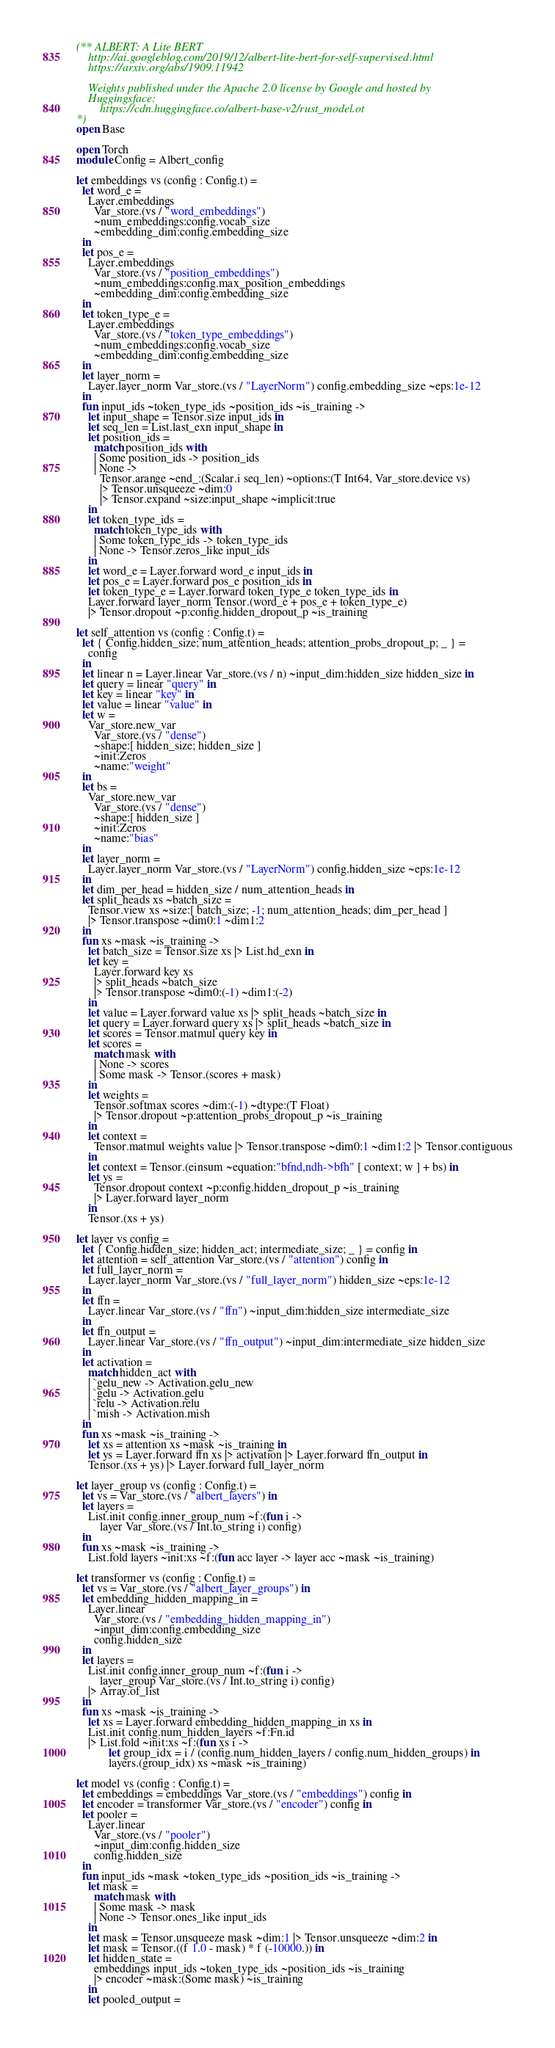<code> <loc_0><loc_0><loc_500><loc_500><_OCaml_>(** ALBERT: A Lite BERT
    http://ai.googleblog.com/2019/12/albert-lite-bert-for-self-supervised.html
    https://arxiv.org/abs/1909.11942

    Weights published under the Apache 2.0 license by Google and hosted by
    Huggingsface:
        https://cdn.huggingface.co/albert-base-v2/rust_model.ot
*)
open Base

open Torch
module Config = Albert_config

let embeddings vs (config : Config.t) =
  let word_e =
    Layer.embeddings
      Var_store.(vs / "word_embeddings")
      ~num_embeddings:config.vocab_size
      ~embedding_dim:config.embedding_size
  in
  let pos_e =
    Layer.embeddings
      Var_store.(vs / "position_embeddings")
      ~num_embeddings:config.max_position_embeddings
      ~embedding_dim:config.embedding_size
  in
  let token_type_e =
    Layer.embeddings
      Var_store.(vs / "token_type_embeddings")
      ~num_embeddings:config.vocab_size
      ~embedding_dim:config.embedding_size
  in
  let layer_norm =
    Layer.layer_norm Var_store.(vs / "LayerNorm") config.embedding_size ~eps:1e-12
  in
  fun input_ids ~token_type_ids ~position_ids ~is_training ->
    let input_shape = Tensor.size input_ids in
    let seq_len = List.last_exn input_shape in
    let position_ids =
      match position_ids with
      | Some position_ids -> position_ids
      | None ->
        Tensor.arange ~end_:(Scalar.i seq_len) ~options:(T Int64, Var_store.device vs)
        |> Tensor.unsqueeze ~dim:0
        |> Tensor.expand ~size:input_shape ~implicit:true
    in
    let token_type_ids =
      match token_type_ids with
      | Some token_type_ids -> token_type_ids
      | None -> Tensor.zeros_like input_ids
    in
    let word_e = Layer.forward word_e input_ids in
    let pos_e = Layer.forward pos_e position_ids in
    let token_type_e = Layer.forward token_type_e token_type_ids in
    Layer.forward layer_norm Tensor.(word_e + pos_e + token_type_e)
    |> Tensor.dropout ~p:config.hidden_dropout_p ~is_training

let self_attention vs (config : Config.t) =
  let { Config.hidden_size; num_attention_heads; attention_probs_dropout_p; _ } =
    config
  in
  let linear n = Layer.linear Var_store.(vs / n) ~input_dim:hidden_size hidden_size in
  let query = linear "query" in
  let key = linear "key" in
  let value = linear "value" in
  let w =
    Var_store.new_var
      Var_store.(vs / "dense")
      ~shape:[ hidden_size; hidden_size ]
      ~init:Zeros
      ~name:"weight"
  in
  let bs =
    Var_store.new_var
      Var_store.(vs / "dense")
      ~shape:[ hidden_size ]
      ~init:Zeros
      ~name:"bias"
  in
  let layer_norm =
    Layer.layer_norm Var_store.(vs / "LayerNorm") config.hidden_size ~eps:1e-12
  in
  let dim_per_head = hidden_size / num_attention_heads in
  let split_heads xs ~batch_size =
    Tensor.view xs ~size:[ batch_size; -1; num_attention_heads; dim_per_head ]
    |> Tensor.transpose ~dim0:1 ~dim1:2
  in
  fun xs ~mask ~is_training ->
    let batch_size = Tensor.size xs |> List.hd_exn in
    let key =
      Layer.forward key xs
      |> split_heads ~batch_size
      |> Tensor.transpose ~dim0:(-1) ~dim1:(-2)
    in
    let value = Layer.forward value xs |> split_heads ~batch_size in
    let query = Layer.forward query xs |> split_heads ~batch_size in
    let scores = Tensor.matmul query key in
    let scores =
      match mask with
      | None -> scores
      | Some mask -> Tensor.(scores + mask)
    in
    let weights =
      Tensor.softmax scores ~dim:(-1) ~dtype:(T Float)
      |> Tensor.dropout ~p:attention_probs_dropout_p ~is_training
    in
    let context =
      Tensor.matmul weights value |> Tensor.transpose ~dim0:1 ~dim1:2 |> Tensor.contiguous
    in
    let context = Tensor.(einsum ~equation:"bfnd,ndh->bfh" [ context; w ] + bs) in
    let ys =
      Tensor.dropout context ~p:config.hidden_dropout_p ~is_training
      |> Layer.forward layer_norm
    in
    Tensor.(xs + ys)

let layer vs config =
  let { Config.hidden_size; hidden_act; intermediate_size; _ } = config in
  let attention = self_attention Var_store.(vs / "attention") config in
  let full_layer_norm =
    Layer.layer_norm Var_store.(vs / "full_layer_norm") hidden_size ~eps:1e-12
  in
  let ffn =
    Layer.linear Var_store.(vs / "ffn") ~input_dim:hidden_size intermediate_size
  in
  let ffn_output =
    Layer.linear Var_store.(vs / "ffn_output") ~input_dim:intermediate_size hidden_size
  in
  let activation =
    match hidden_act with
    | `gelu_new -> Activation.gelu_new
    | `gelu -> Activation.gelu
    | `relu -> Activation.relu
    | `mish -> Activation.mish
  in
  fun xs ~mask ~is_training ->
    let xs = attention xs ~mask ~is_training in
    let ys = Layer.forward ffn xs |> activation |> Layer.forward ffn_output in
    Tensor.(xs + ys) |> Layer.forward full_layer_norm

let layer_group vs (config : Config.t) =
  let vs = Var_store.(vs / "albert_layers") in
  let layers =
    List.init config.inner_group_num ~f:(fun i ->
        layer Var_store.(vs / Int.to_string i) config)
  in
  fun xs ~mask ~is_training ->
    List.fold layers ~init:xs ~f:(fun acc layer -> layer acc ~mask ~is_training)

let transformer vs (config : Config.t) =
  let vs = Var_store.(vs / "albert_layer_groups") in
  let embedding_hidden_mapping_in =
    Layer.linear
      Var_store.(vs / "embedding_hidden_mapping_in")
      ~input_dim:config.embedding_size
      config.hidden_size
  in
  let layers =
    List.init config.inner_group_num ~f:(fun i ->
        layer_group Var_store.(vs / Int.to_string i) config)
    |> Array.of_list
  in
  fun xs ~mask ~is_training ->
    let xs = Layer.forward embedding_hidden_mapping_in xs in
    List.init config.num_hidden_layers ~f:Fn.id
    |> List.fold ~init:xs ~f:(fun xs i ->
           let group_idx = i / (config.num_hidden_layers / config.num_hidden_groups) in
           layers.(group_idx) xs ~mask ~is_training)

let model vs (config : Config.t) =
  let embeddings = embeddings Var_store.(vs / "embeddings") config in
  let encoder = transformer Var_store.(vs / "encoder") config in
  let pooler =
    Layer.linear
      Var_store.(vs / "pooler")
      ~input_dim:config.hidden_size
      config.hidden_size
  in
  fun input_ids ~mask ~token_type_ids ~position_ids ~is_training ->
    let mask =
      match mask with
      | Some mask -> mask
      | None -> Tensor.ones_like input_ids
    in
    let mask = Tensor.unsqueeze mask ~dim:1 |> Tensor.unsqueeze ~dim:2 in
    let mask = Tensor.((f 1.0 - mask) * f (-10000.)) in
    let hidden_state =
      embeddings input_ids ~token_type_ids ~position_ids ~is_training
      |> encoder ~mask:(Some mask) ~is_training
    in
    let pooled_output =</code> 